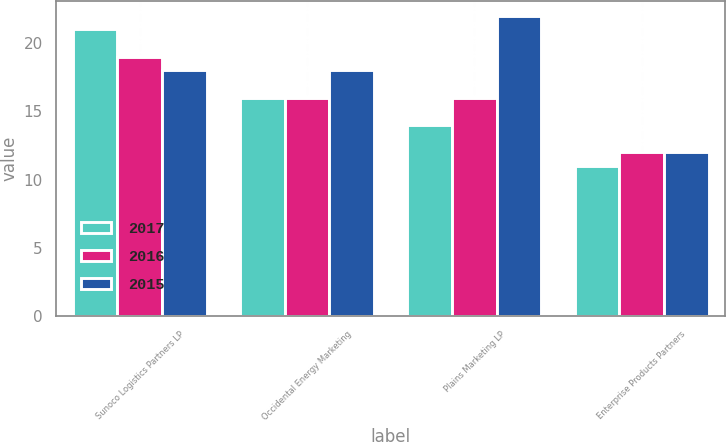<chart> <loc_0><loc_0><loc_500><loc_500><stacked_bar_chart><ecel><fcel>Sunoco Logistics Partners LP<fcel>Occidental Energy Marketing<fcel>Plains Marketing LP<fcel>Enterprise Products Partners<nl><fcel>2017<fcel>21<fcel>16<fcel>14<fcel>11<nl><fcel>2016<fcel>19<fcel>16<fcel>16<fcel>12<nl><fcel>2015<fcel>18<fcel>18<fcel>22<fcel>12<nl></chart> 